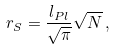Convert formula to latex. <formula><loc_0><loc_0><loc_500><loc_500>r _ { S } = \frac { l _ { P l } } { \sqrt { \pi } } \sqrt { N } \, ,</formula> 